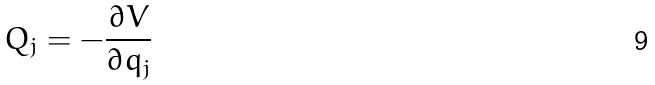Convert formula to latex. <formula><loc_0><loc_0><loc_500><loc_500>Q _ { j } = - \frac { \partial V } { \partial q _ { j } }</formula> 